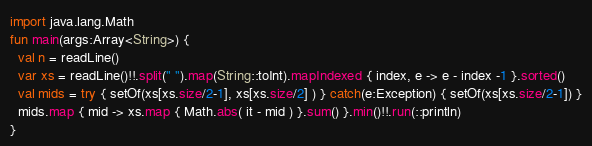Convert code to text. <code><loc_0><loc_0><loc_500><loc_500><_Kotlin_>import java.lang.Math
fun main(args:Array<String>) {
  val n = readLine()
  var xs = readLine()!!.split(" ").map(String::toInt).mapIndexed { index, e -> e - index -1 }.sorted()
  val mids = try { setOf(xs[xs.size/2-1], xs[xs.size/2] ) } catch(e:Exception) { setOf(xs[xs.size/2-1]) }
  mids.map { mid -> xs.map { Math.abs( it - mid ) }.sum() }.min()!!.run(::println)
}</code> 